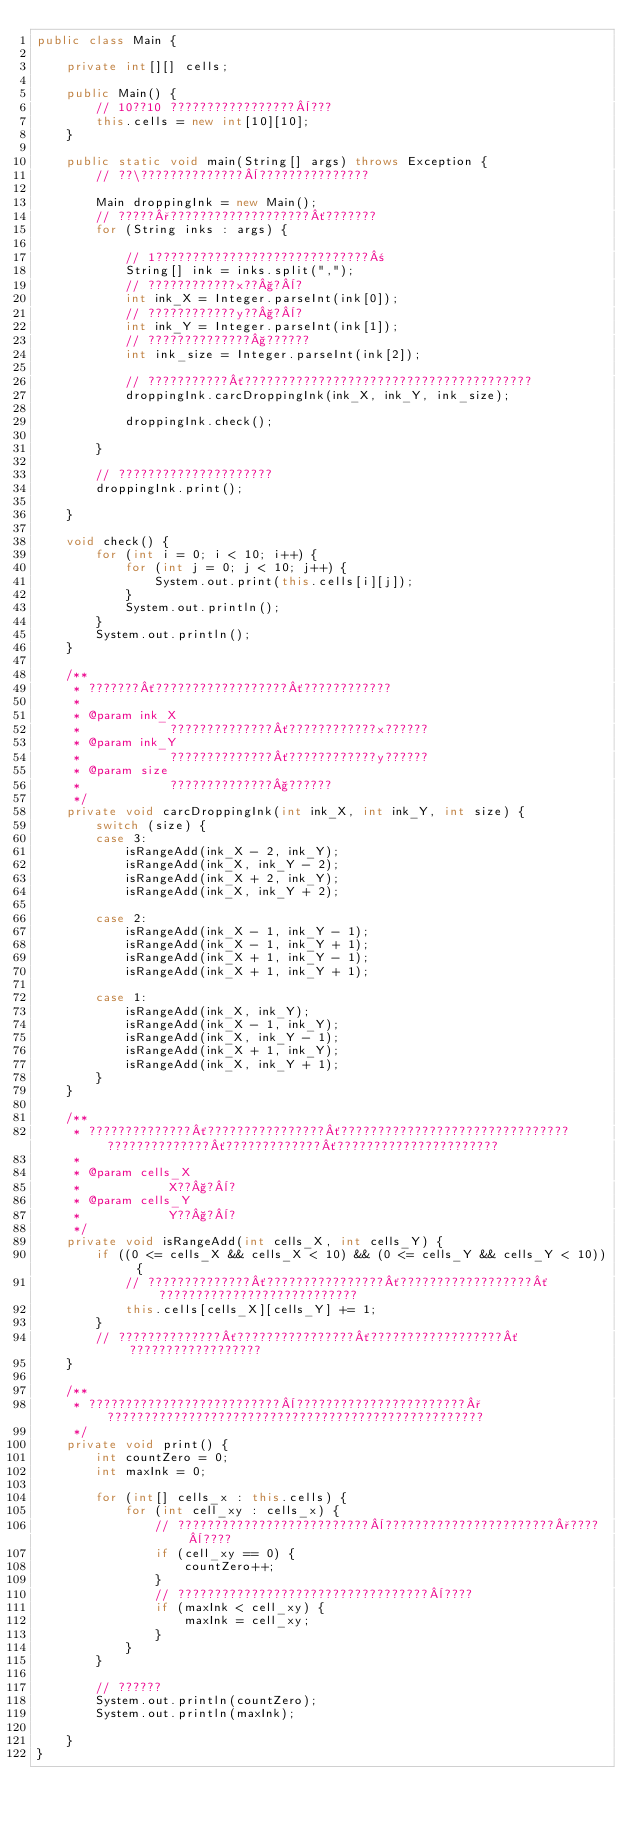<code> <loc_0><loc_0><loc_500><loc_500><_Java_>public class Main {

    private int[][] cells;

    public Main() {
        // 10??10 ?????????????????¨???
        this.cells = new int[10][10];
    }

    public static void main(String[] args) throws Exception {
        // ??\??????????????¨???????????????

        Main droppingInk = new Main();
        // ?????°???????????????????´???????
        for (String inks : args) {

            // 1?????????????????????????????±
            String[] ink = inks.split(",");
            // ????????????x??§?¨?
            int ink_X = Integer.parseInt(ink[0]);
            // ????????????y??§?¨?
            int ink_Y = Integer.parseInt(ink[1]);
            // ??????????????§??????
            int ink_size = Integer.parseInt(ink[2]);

            // ???????????´???????????????????????????????????????
            droppingInk.carcDroppingInk(ink_X, ink_Y, ink_size);

            droppingInk.check();

        }

        // ?????????????????????
        droppingInk.print();

    }

    void check() {
        for (int i = 0; i < 10; i++) {
            for (int j = 0; j < 10; j++) {
                System.out.print(this.cells[i][j]);
            }
            System.out.println();
        }
        System.out.println();
    }

    /**
     * ???????´??????????????????´????????????
     *
     * @param ink_X
     *            ??????????????´????????????x??????
     * @param ink_Y
     *            ??????????????´????????????y??????
     * @param size
     *            ??????????????§??????
     */
    private void carcDroppingInk(int ink_X, int ink_Y, int size) {
        switch (size) {
        case 3:
            isRangeAdd(ink_X - 2, ink_Y);
            isRangeAdd(ink_X, ink_Y - 2);
            isRangeAdd(ink_X + 2, ink_Y);
            isRangeAdd(ink_X, ink_Y + 2);

        case 2:
            isRangeAdd(ink_X - 1, ink_Y - 1);
            isRangeAdd(ink_X - 1, ink_Y + 1);
            isRangeAdd(ink_X + 1, ink_Y - 1);
            isRangeAdd(ink_X + 1, ink_Y + 1);

        case 1:
            isRangeAdd(ink_X, ink_Y);
            isRangeAdd(ink_X - 1, ink_Y);
            isRangeAdd(ink_X, ink_Y - 1);
            isRangeAdd(ink_X + 1, ink_Y);
            isRangeAdd(ink_X, ink_Y + 1);
        }
    }

    /**
     * ??????????????´????????????????´??????????????????????????????? ??????????????´?????????????´??????????????????????
     *
     * @param cells_X
     *            X??§?¨?
     * @param cells_Y
     *            Y??§?¨?
     */
    private void isRangeAdd(int cells_X, int cells_Y) {
        if ((0 <= cells_X && cells_X < 10) && (0 <= cells_Y && cells_Y < 10)) {
            // ??????????????´????????????????´??????????????????´???????????????????????????
            this.cells[cells_X][cells_Y] += 1;
        }
        // ??????????????´????????????????´??????????????????´??????????????????
    }

    /**
     * ??????????????????????????¨???????????????????????°???????????????????????????????????????????????????
     */
    private void print() {
        int countZero = 0;
        int maxInk = 0;

        for (int[] cells_x : this.cells) {
            for (int cell_xy : cells_x) {
                // ??????????????????????????¨???????????????????????°????¨????
                if (cell_xy == 0) {
                    countZero++;
                }
                // ??????????????????????????????????¨????
                if (maxInk < cell_xy) {
                    maxInk = cell_xy;
                }
            }
        }

        // ??????
        System.out.println(countZero);
        System.out.println(maxInk);

    }
}</code> 